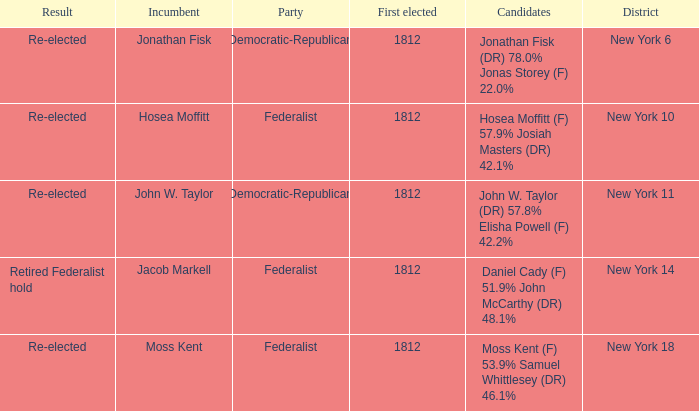Name the incumbent for new york 10 Hosea Moffitt. 